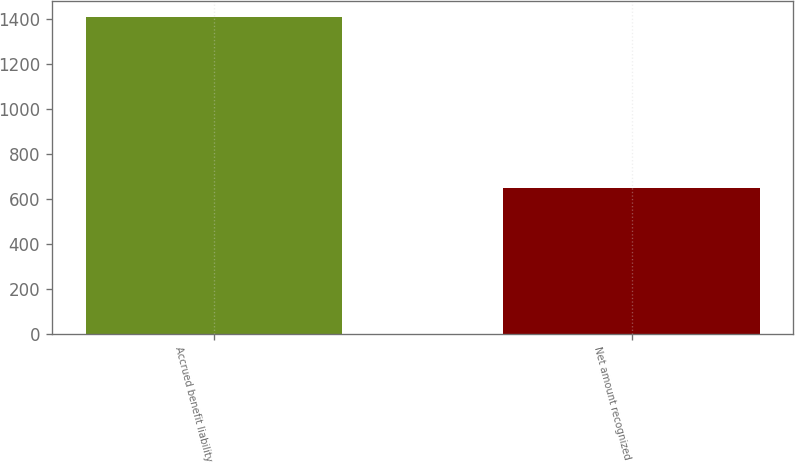<chart> <loc_0><loc_0><loc_500><loc_500><bar_chart><fcel>Accrued benefit liability<fcel>Net amount recognized<nl><fcel>1412<fcel>650<nl></chart> 